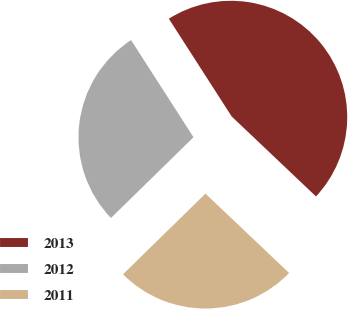Convert chart. <chart><loc_0><loc_0><loc_500><loc_500><pie_chart><fcel>2013<fcel>2012<fcel>2011<nl><fcel>46.17%<fcel>28.23%<fcel>25.59%<nl></chart> 